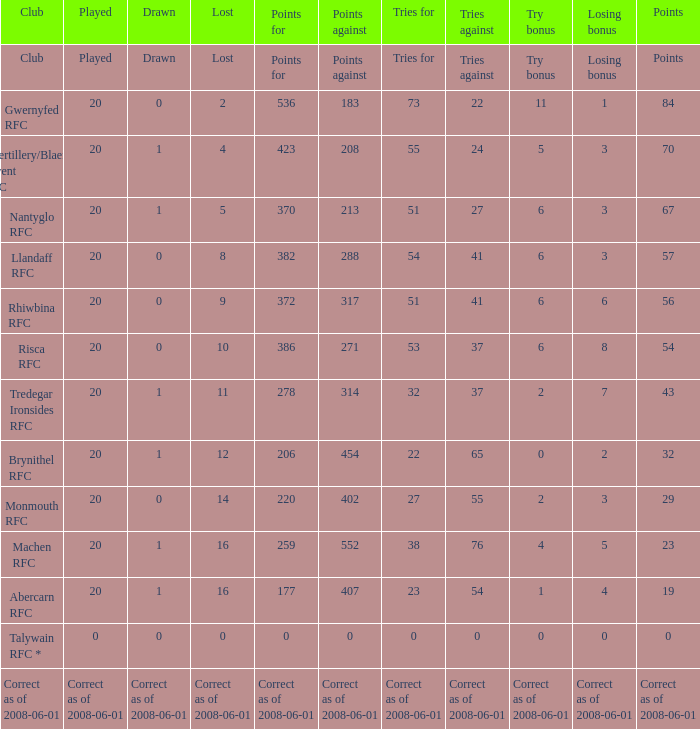If the points were 0, what was the losing bonus? 0.0. 